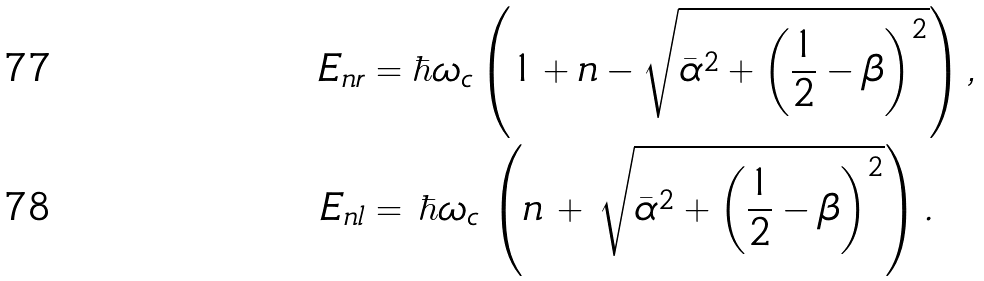Convert formula to latex. <formula><loc_0><loc_0><loc_500><loc_500>E _ { n r } & = \hbar { \omega } _ { c } \left ( 1 + n - \sqrt { \bar { \alpha } ^ { 2 } + \left ( \frac { 1 } { 2 } - \beta \right ) ^ { 2 } } \right ) , \\ E _ { n l } & = \, \hbar { \omega } _ { c } \, \left ( n \, + \, \sqrt { \bar { \alpha } ^ { 2 } + \left ( \frac { 1 } { 2 } - \beta \right ) ^ { 2 } } \right ) .</formula> 